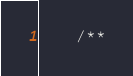<code> <loc_0><loc_0><loc_500><loc_500><_PHP_>
    /**</code> 